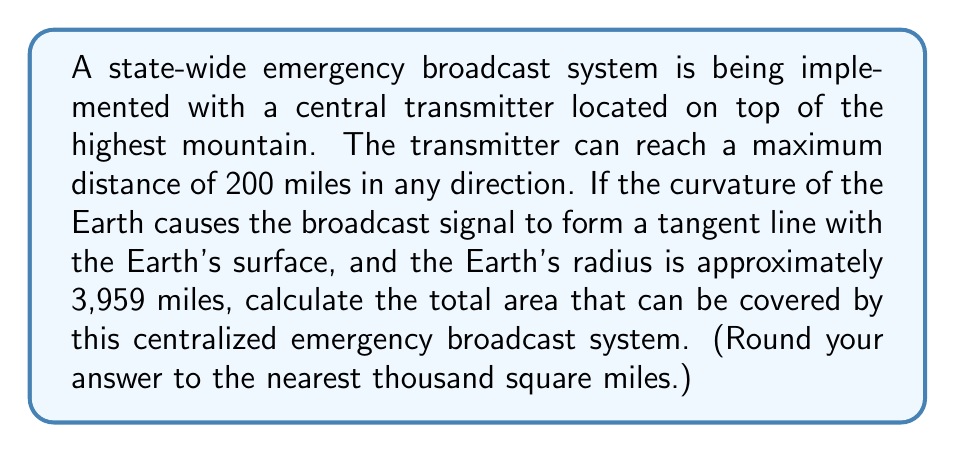Teach me how to tackle this problem. Let's approach this step-by-step:

1) First, we need to visualize the problem. The broadcast area forms a circular cap on the Earth's surface.

2) Let's define our variables:
   $R$ = Earth's radius = 3,959 miles
   $d$ = maximum broadcast distance = 200 miles
   $\theta$ = central angle (in radians)

3) We can use the right triangle formed by the Earth's center, the transmitter, and the edge of the broadcast range:

   $$\cos\theta = \frac{R}{R+d}$$

4) Solving for $\theta$:

   $$\theta = \arccos(\frac{R}{R+d}) = \arccos(\frac{3959}{3959+200}) \approx 0.2234 \text{ radians}$$

5) The area of a spherical cap is given by the formula:

   $$A = 2\pi R^2(1-\cos\theta)$$

6) Substituting our values:

   $$A = 2\pi(3959)^2(1-\cos(0.2234))$$

7) Calculating:

   $$A \approx 246,897 \text{ square miles}$$

8) Rounding to the nearest thousand:

   $$A \approx 247,000 \text{ square miles}$$
Answer: 247,000 square miles 